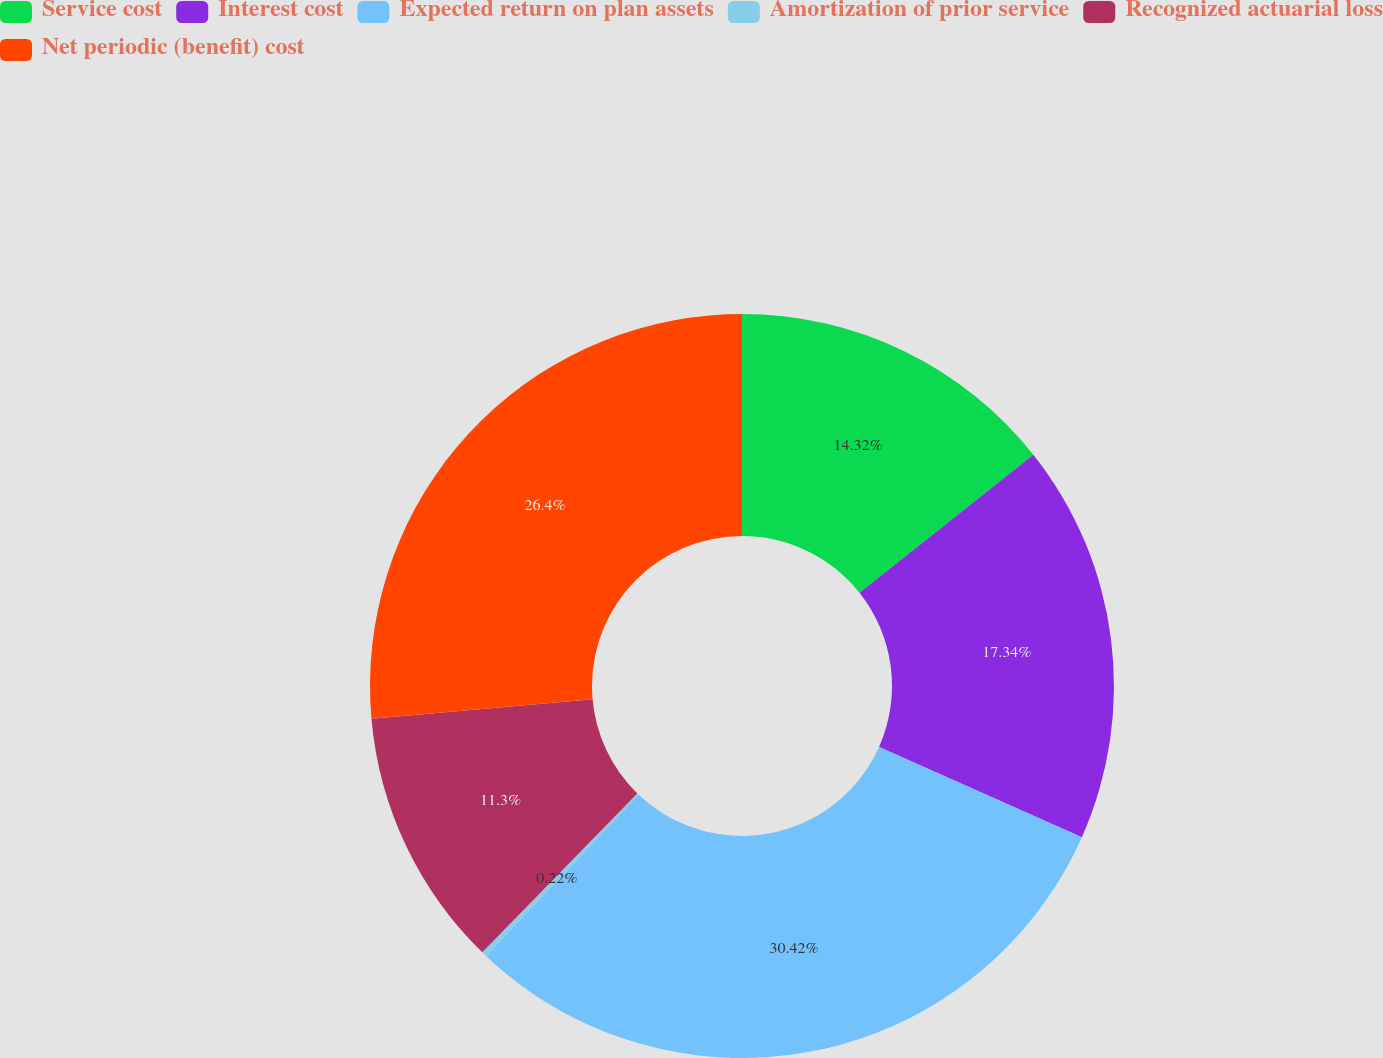<chart> <loc_0><loc_0><loc_500><loc_500><pie_chart><fcel>Service cost<fcel>Interest cost<fcel>Expected return on plan assets<fcel>Amortization of prior service<fcel>Recognized actuarial loss<fcel>Net periodic (benefit) cost<nl><fcel>14.32%<fcel>17.34%<fcel>30.42%<fcel>0.22%<fcel>11.3%<fcel>26.4%<nl></chart> 